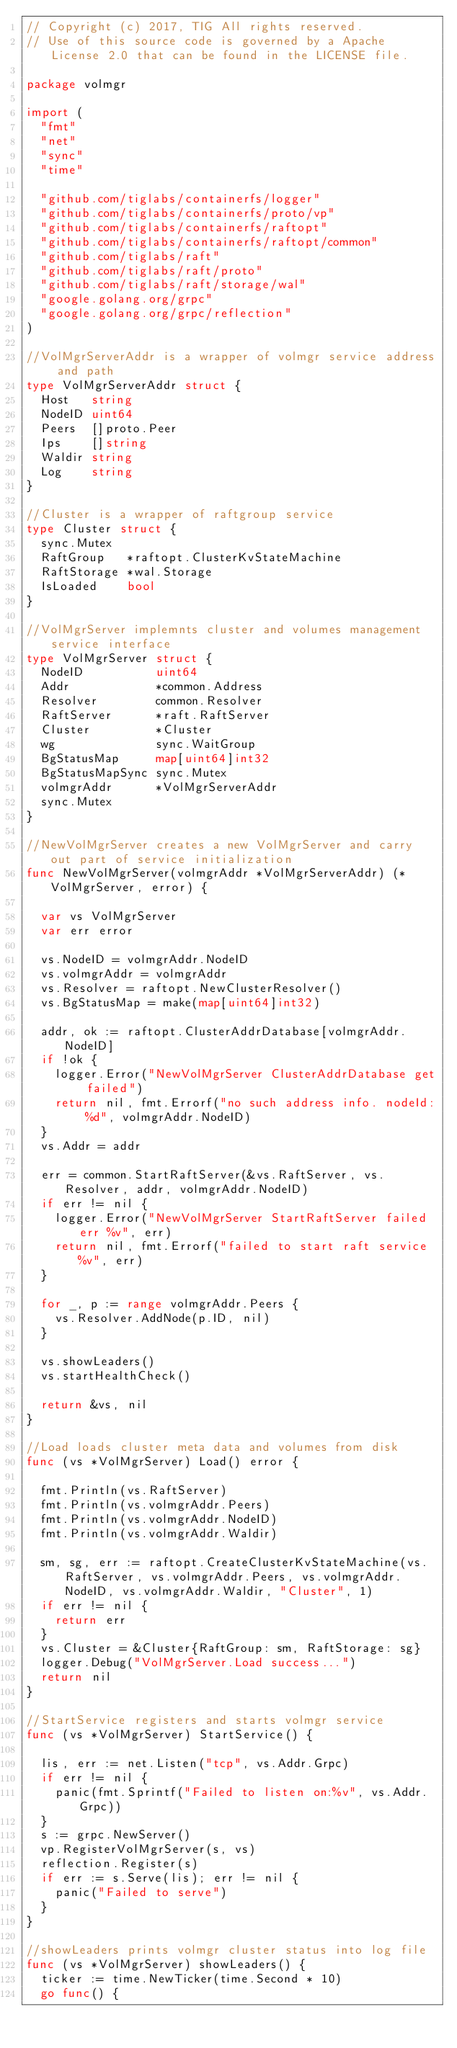<code> <loc_0><loc_0><loc_500><loc_500><_Go_>// Copyright (c) 2017, TIG All rights reserved.
// Use of this source code is governed by a Apache License 2.0 that can be found in the LICENSE file.

package volmgr

import (
	"fmt"
	"net"
	"sync"
	"time"

	"github.com/tiglabs/containerfs/logger"
	"github.com/tiglabs/containerfs/proto/vp"
	"github.com/tiglabs/containerfs/raftopt"
	"github.com/tiglabs/containerfs/raftopt/common"
	"github.com/tiglabs/raft"
	"github.com/tiglabs/raft/proto"
	"github.com/tiglabs/raft/storage/wal"
	"google.golang.org/grpc"
	"google.golang.org/grpc/reflection"
)

//VolMgrServerAddr is a wrapper of volmgr service address and path
type VolMgrServerAddr struct {
	Host   string
	NodeID uint64
	Peers  []proto.Peer
	Ips    []string
	Waldir string
	Log    string
}

//Cluster is a wrapper of raftgroup service
type Cluster struct {
	sync.Mutex
	RaftGroup   *raftopt.ClusterKvStateMachine
	RaftStorage *wal.Storage
	IsLoaded    bool
}

//VolMgrServer implemnts cluster and volumes management service interface
type VolMgrServer struct {
	NodeID          uint64
	Addr            *common.Address
	Resolver        common.Resolver
	RaftServer      *raft.RaftServer
	Cluster         *Cluster
	wg              sync.WaitGroup
	BgStatusMap     map[uint64]int32
	BgStatusMapSync sync.Mutex
	volmgrAddr      *VolMgrServerAddr
	sync.Mutex
}

//NewVolMgrServer creates a new VolMgrServer and carry out part of service initialization
func NewVolMgrServer(volmgrAddr *VolMgrServerAddr) (*VolMgrServer, error) {

	var vs VolMgrServer
	var err error

	vs.NodeID = volmgrAddr.NodeID
	vs.volmgrAddr = volmgrAddr
	vs.Resolver = raftopt.NewClusterResolver()
	vs.BgStatusMap = make(map[uint64]int32)

	addr, ok := raftopt.ClusterAddrDatabase[volmgrAddr.NodeID]
	if !ok {
		logger.Error("NewVolMgrServer ClusterAddrDatabase get failed")
		return nil, fmt.Errorf("no such address info. nodeId: %d", volmgrAddr.NodeID)
	}
	vs.Addr = addr

	err = common.StartRaftServer(&vs.RaftServer, vs.Resolver, addr, volmgrAddr.NodeID)
	if err != nil {
		logger.Error("NewVolMgrServer StartRaftServer failed err %v", err)
		return nil, fmt.Errorf("failed to start raft service %v", err)
	}

	for _, p := range volmgrAddr.Peers {
		vs.Resolver.AddNode(p.ID, nil)
	}

	vs.showLeaders()
	vs.startHealthCheck()

	return &vs, nil
}

//Load loads cluster meta data and volumes from disk
func (vs *VolMgrServer) Load() error {

	fmt.Println(vs.RaftServer)
	fmt.Println(vs.volmgrAddr.Peers)
	fmt.Println(vs.volmgrAddr.NodeID)
	fmt.Println(vs.volmgrAddr.Waldir)

	sm, sg, err := raftopt.CreateClusterKvStateMachine(vs.RaftServer, vs.volmgrAddr.Peers, vs.volmgrAddr.NodeID, vs.volmgrAddr.Waldir, "Cluster", 1)
	if err != nil {
		return err
	}
	vs.Cluster = &Cluster{RaftGroup: sm, RaftStorage: sg}
	logger.Debug("VolMgrServer.Load success...")
	return nil
}

//StartService registers and starts volmgr service
func (vs *VolMgrServer) StartService() {

	lis, err := net.Listen("tcp", vs.Addr.Grpc)
	if err != nil {
		panic(fmt.Sprintf("Failed to listen on:%v", vs.Addr.Grpc))
	}
	s := grpc.NewServer()
	vp.RegisterVolMgrServer(s, vs)
	reflection.Register(s)
	if err := s.Serve(lis); err != nil {
		panic("Failed to serve")
	}
}

//showLeaders prints volmgr cluster status into log file
func (vs *VolMgrServer) showLeaders() {
	ticker := time.NewTicker(time.Second * 10)
	go func() {</code> 